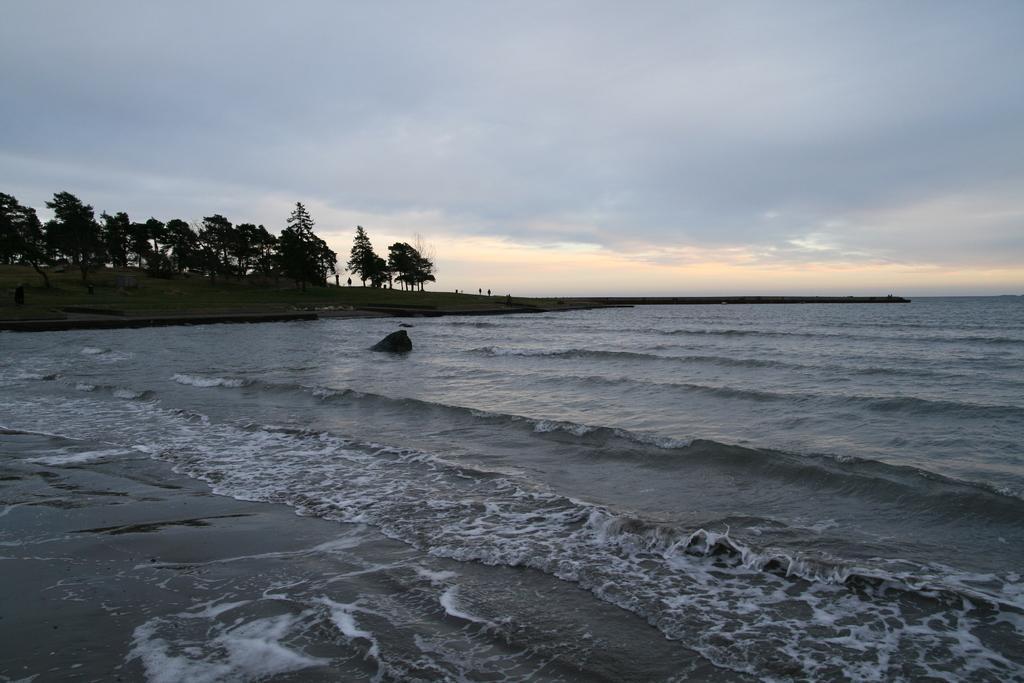In one or two sentences, can you explain what this image depicts? This image is taken outdoors. At the top of the image there is the sky with clouds. At the bottom of the image there is the sea. On the left side of the image there are many trees with leaves, stems and branches. 